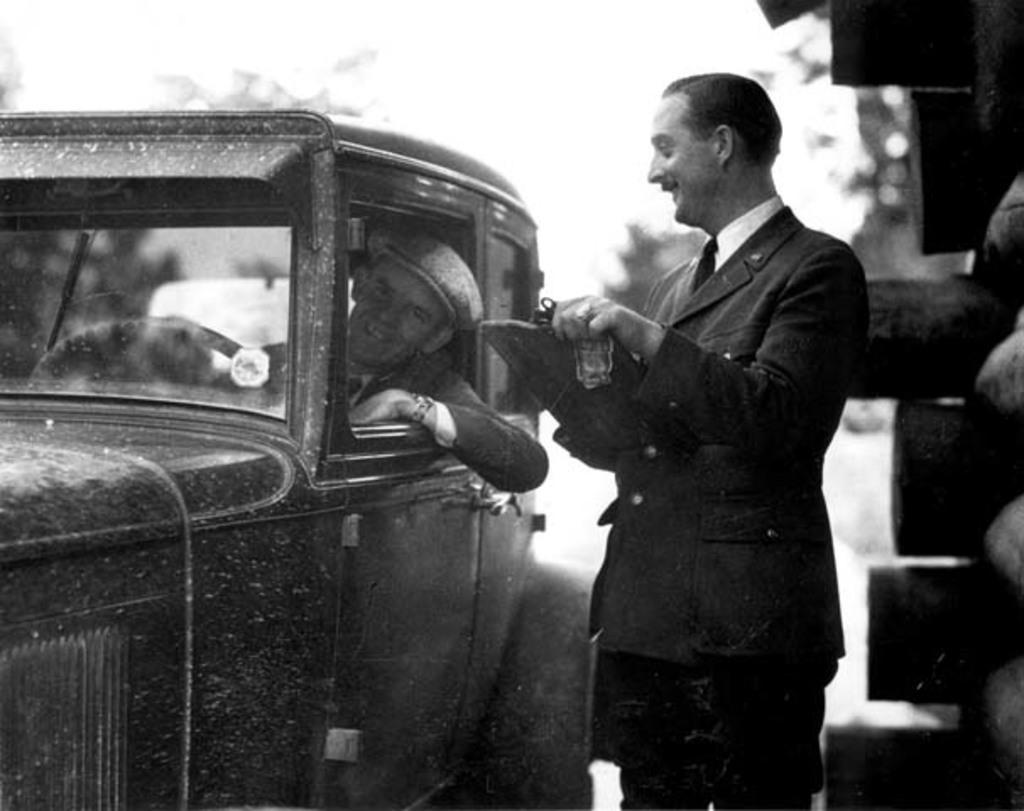How would you summarize this image in a sentence or two? In the image we can see there is a man who is standing. There is another man sitting in the car and the image is in black and white colour. 